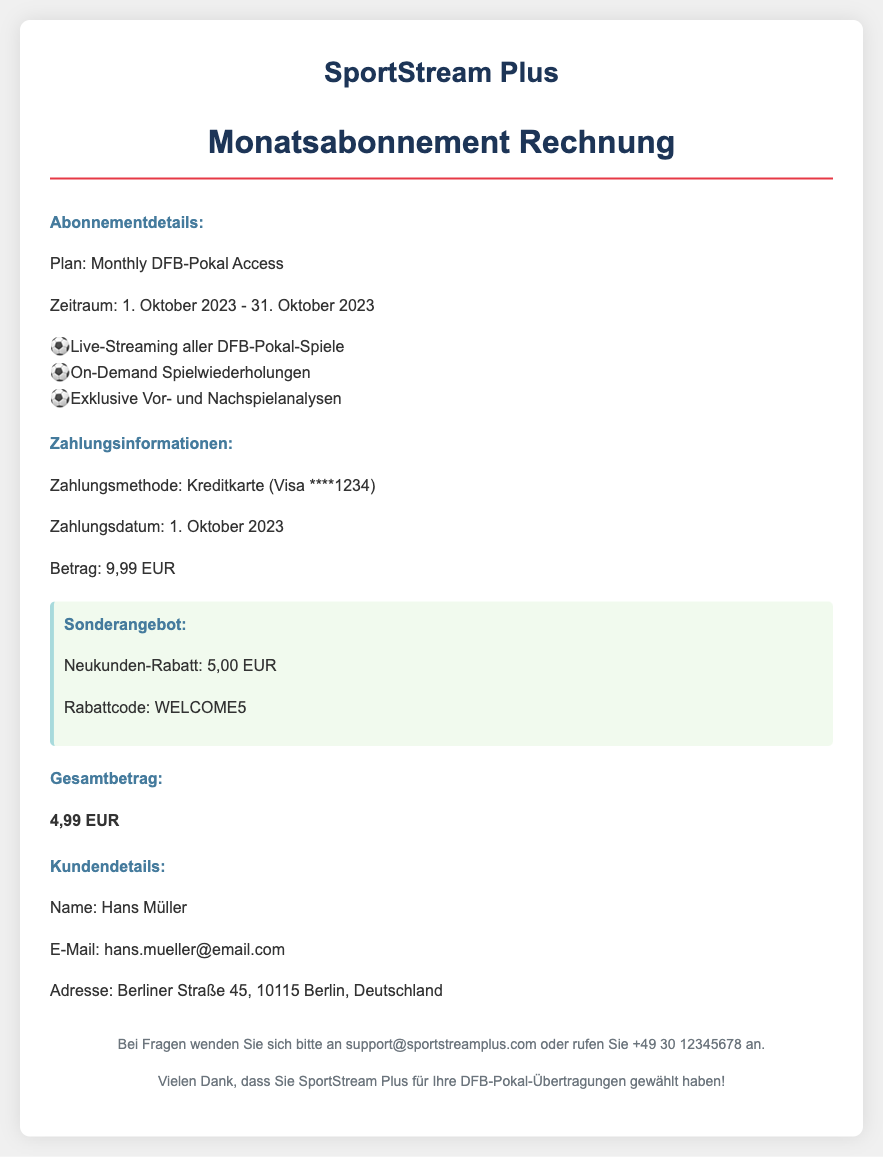What is the subscription plan? The subscription plan refers to the type of service provided, which is detailed in the document.
Answer: Monthly DFB-Pokal Access What is the billing amount before discount? The billing amount before applying any discounts can be found in the payment information section.
Answer: 9,99 EUR What is the discount amount applied? The discount amount indicates the reduction applied to the total bill, specifically for new customers, as mentioned in the document.
Answer: 5,00 EUR What is the total amount after discount? The total amount after discount is the final charge to the customer after applying the promotional discount, as indicated in the document.
Answer: 4,99 EUR What date was the payment processed? The date the payment was made is specified within the payment information in the document.
Answer: 1. Oktober 2023 What is the payment method used? The method used for payment can be identified under the payment information section.
Answer: Kreditkarte (Visa ****1234) Who is the customer listed on the receipt? The customer's name is provided in the customer details section of the document.
Answer: Hans Müller What is the address of the customer? The customer's address is specified in the customer details, which is essential for billing purposes.
Answer: Berliner Straße 45, 10115 Berlin, Deutschland What is the validity period of the subscription? The validity period indicates the start and end date of the subscription service provided, mentioned in the document.
Answer: 1. Oktober 2023 - 31. Oktober 2023 